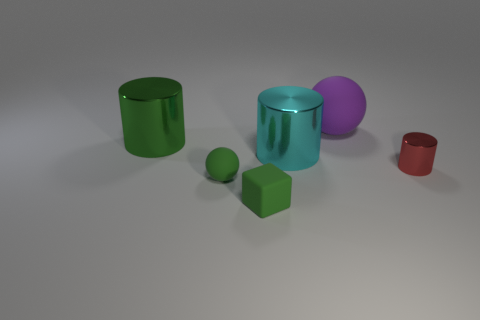There is a matte sphere that is left of the cube; is it the same color as the shiny object that is behind the large cyan shiny cylinder?
Provide a succinct answer. Yes. How many green rubber things are the same size as the green rubber ball?
Your response must be concise. 1. What size is the metallic thing that is the same color as the block?
Your response must be concise. Large. Is the color of the tiny shiny cylinder the same as the small ball?
Keep it short and to the point. No. What is the shape of the big matte object?
Your response must be concise. Sphere. Is there another big rubber sphere of the same color as the large sphere?
Keep it short and to the point. No. Is the number of small blocks behind the big purple matte ball greater than the number of large yellow balls?
Give a very brief answer. No. There is a cyan object; is its shape the same as the small thing that is in front of the tiny green rubber ball?
Your answer should be very brief. No. Is there a purple metallic object?
Your response must be concise. No. What number of small objects are either spheres or cyan metallic things?
Provide a short and direct response. 1. 